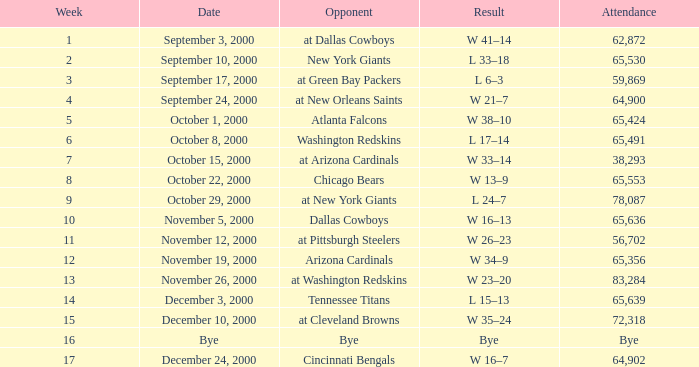What was the attendance for week 2? 65530.0. Would you mind parsing the complete table? {'header': ['Week', 'Date', 'Opponent', 'Result', 'Attendance'], 'rows': [['1', 'September 3, 2000', 'at Dallas Cowboys', 'W 41–14', '62,872'], ['2', 'September 10, 2000', 'New York Giants', 'L 33–18', '65,530'], ['3', 'September 17, 2000', 'at Green Bay Packers', 'L 6–3', '59,869'], ['4', 'September 24, 2000', 'at New Orleans Saints', 'W 21–7', '64,900'], ['5', 'October 1, 2000', 'Atlanta Falcons', 'W 38–10', '65,424'], ['6', 'October 8, 2000', 'Washington Redskins', 'L 17–14', '65,491'], ['7', 'October 15, 2000', 'at Arizona Cardinals', 'W 33–14', '38,293'], ['8', 'October 22, 2000', 'Chicago Bears', 'W 13–9', '65,553'], ['9', 'October 29, 2000', 'at New York Giants', 'L 24–7', '78,087'], ['10', 'November 5, 2000', 'Dallas Cowboys', 'W 16–13', '65,636'], ['11', 'November 12, 2000', 'at Pittsburgh Steelers', 'W 26–23', '56,702'], ['12', 'November 19, 2000', 'Arizona Cardinals', 'W 34–9', '65,356'], ['13', 'November 26, 2000', 'at Washington Redskins', 'W 23–20', '83,284'], ['14', 'December 3, 2000', 'Tennessee Titans', 'L 15–13', '65,639'], ['15', 'December 10, 2000', 'at Cleveland Browns', 'W 35–24', '72,318'], ['16', 'Bye', 'Bye', 'Bye', 'Bye'], ['17', 'December 24, 2000', 'Cincinnati Bengals', 'W 16–7', '64,902']]} 